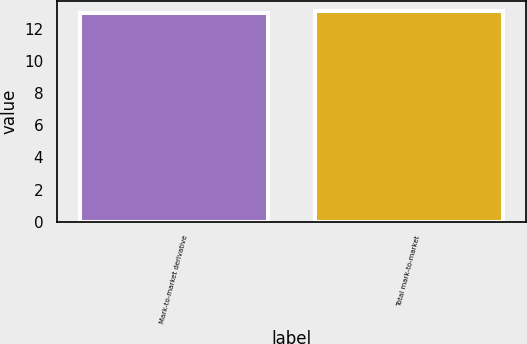<chart> <loc_0><loc_0><loc_500><loc_500><bar_chart><fcel>Mark-to-market derivative<fcel>Total mark-to-market<nl><fcel>13<fcel>13.1<nl></chart> 